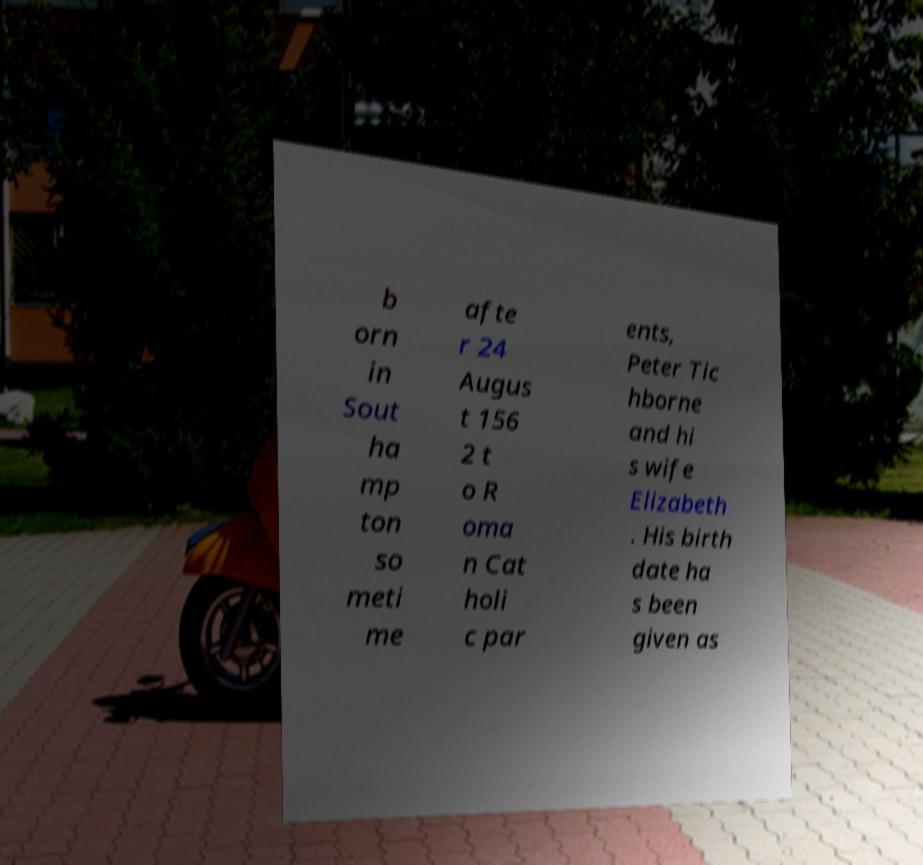Could you assist in decoding the text presented in this image and type it out clearly? b orn in Sout ha mp ton so meti me afte r 24 Augus t 156 2 t o R oma n Cat holi c par ents, Peter Tic hborne and hi s wife Elizabeth . His birth date ha s been given as 